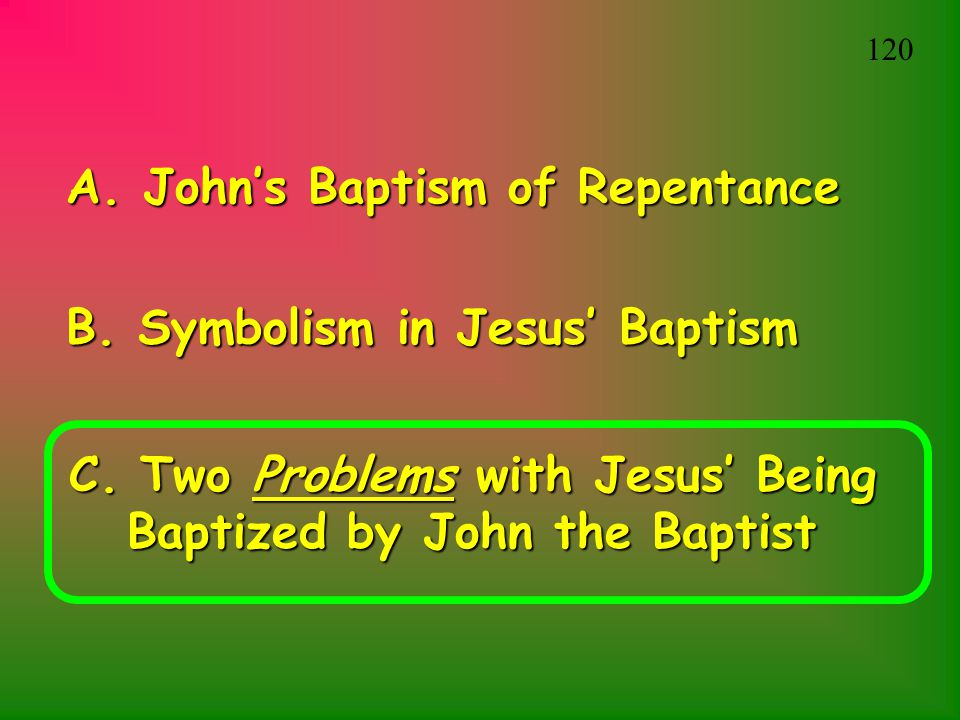What does the presentation seem to focus on based on the slide content provided? Based on the slide content, the presentation appears to focus on the Christian sacrament of baptism, particularly in the context of Jesus Christ. It might explore the historical aspects of John's baptism, the symbolic meanings behind Jesus' baptism, and address certain challenges or theological discussions surrounding Jesus being baptized by John the Baptist. Can you explain why the issue of Jesus being baptized by John could be problematic? The issue of Jesus being baptized by John the Baptist can be seen as problematic for a few reasons. Firstly, John's baptism was meant for repentance and forgiveness of sins. Since Christian belief holds that Jesus was sinless, the necessity of his baptism could be questioned. Secondly, it could appear contradictory for Jesus, considered divine, to submit to a human ritual. These issues may lead to theological discussions on the nature of Jesus' humility, identification with humanity, and the fulfillment of righteousness. How does the symbolism in Jesus' baptism enhance our understanding of his mission and message? The symbolism in Jesus' baptism enhances our understanding of his mission and message in several profound ways. Firstly, it signifies Jesus' official entrance into his public ministry, marking a shift from his private life to his role as a teacher and savior. The act of baptism itself symbolizes purification and the forgiveness of sins, which aligns with Jesus' mission to bring salvation to humanity. The descent of the Holy Spirit during his baptism represents divine approval and empowerment, affirming Jesus' divine sonship and authority. Additionally, by being baptized, Jesus identifies with humanity's need for repentance, showcasing his humility and solidarity with those he came to save. Imagine a scenario in which another figure of historical or religious significance were baptized by John. What might be some implications or outcomes of such an event? Imagine if a figure like Moses, known for leading the Israelites out of Egypt and receiving the Ten Commandments, were to be baptized by John. This event would carry deep implications and outcomes. It would symbolize Moses' acceptance of a new covenant, bridging the gap between the Old and New Testaments. Such a baptism could signify a shift from the Mosaic Law to the grace and redemption offered through Jesus Christ, uniting the messages of both figures. Additionally, it could serve as a powerful act of humility and renewal for a leader who had already played a pivotal role in shaping religious history. This scenario would foster a deeper understanding of continuity and evolution within the faith tradition, highlighting themes of redemption, law, and divine guidance. 